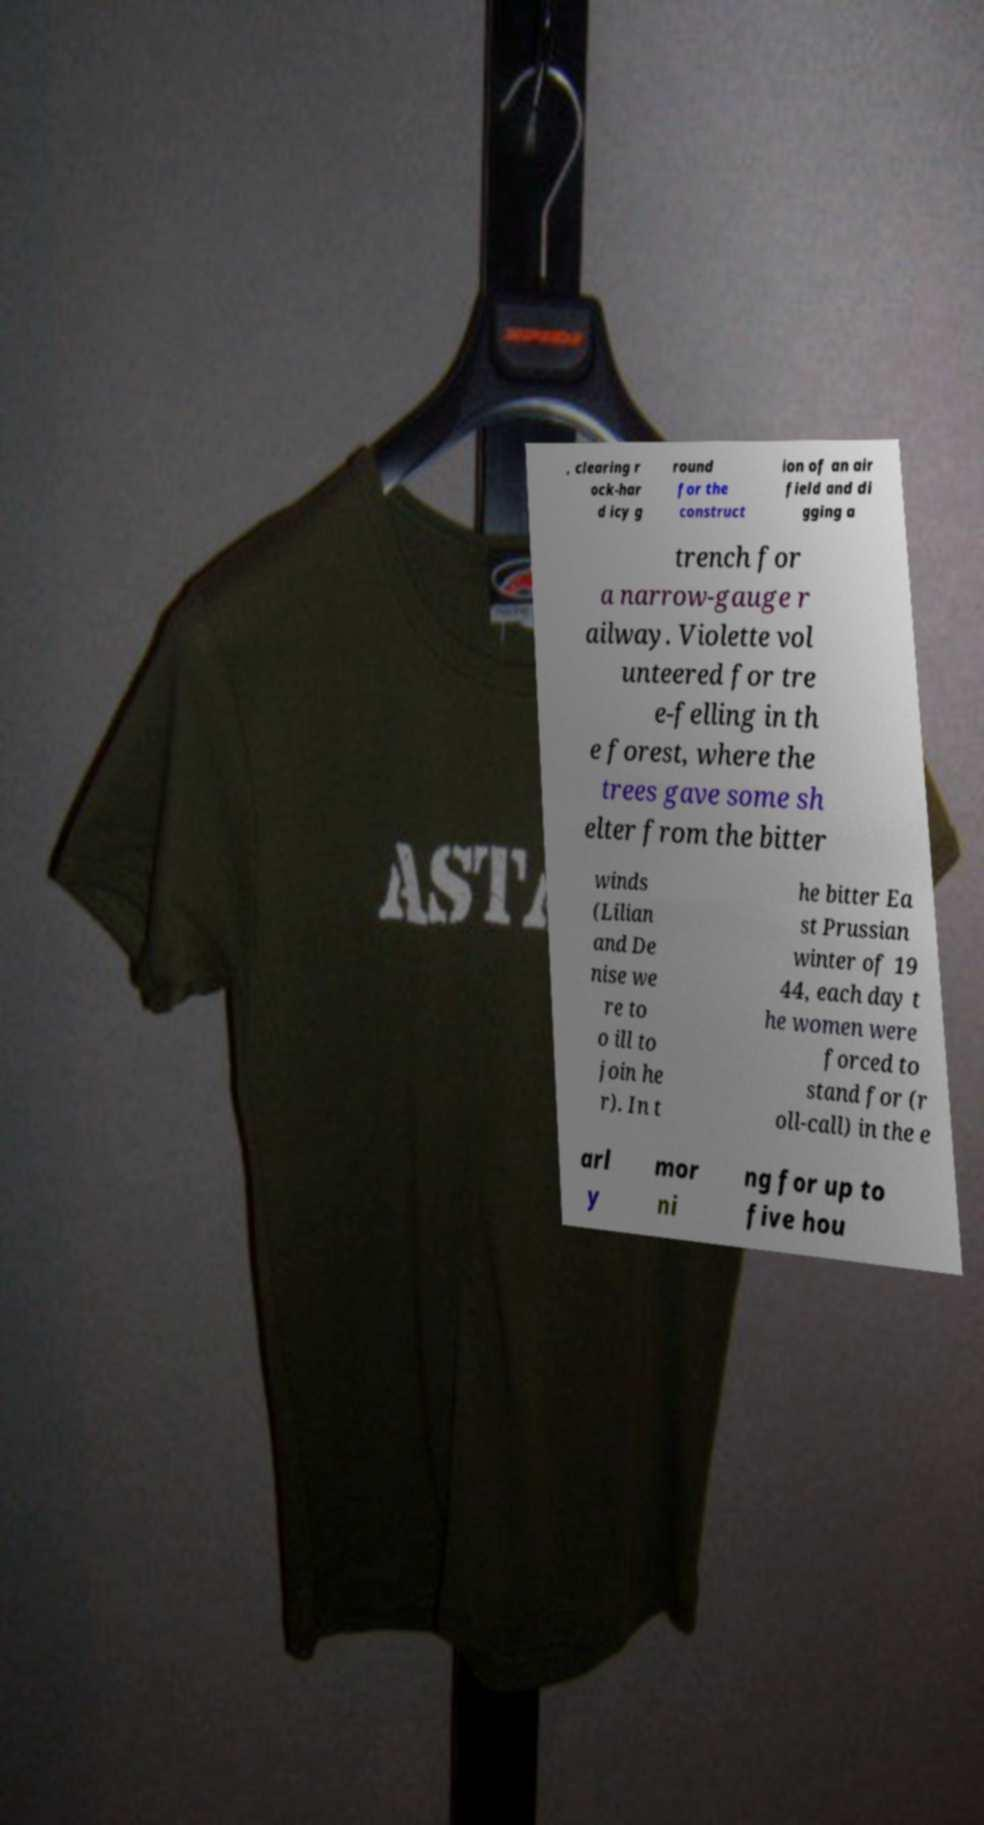For documentation purposes, I need the text within this image transcribed. Could you provide that? , clearing r ock-har d icy g round for the construct ion of an air field and di gging a trench for a narrow-gauge r ailway. Violette vol unteered for tre e-felling in th e forest, where the trees gave some sh elter from the bitter winds (Lilian and De nise we re to o ill to join he r). In t he bitter Ea st Prussian winter of 19 44, each day t he women were forced to stand for (r oll-call) in the e arl y mor ni ng for up to five hou 